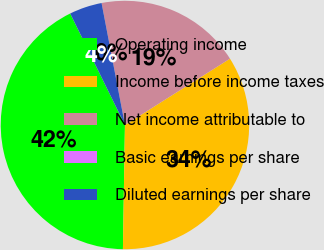<chart> <loc_0><loc_0><loc_500><loc_500><pie_chart><fcel>Operating income<fcel>Income before income taxes<fcel>Net income attributable to<fcel>Basic earnings per share<fcel>Diluted earnings per share<nl><fcel>42.48%<fcel>34.23%<fcel>19.05%<fcel>0.0%<fcel>4.25%<nl></chart> 